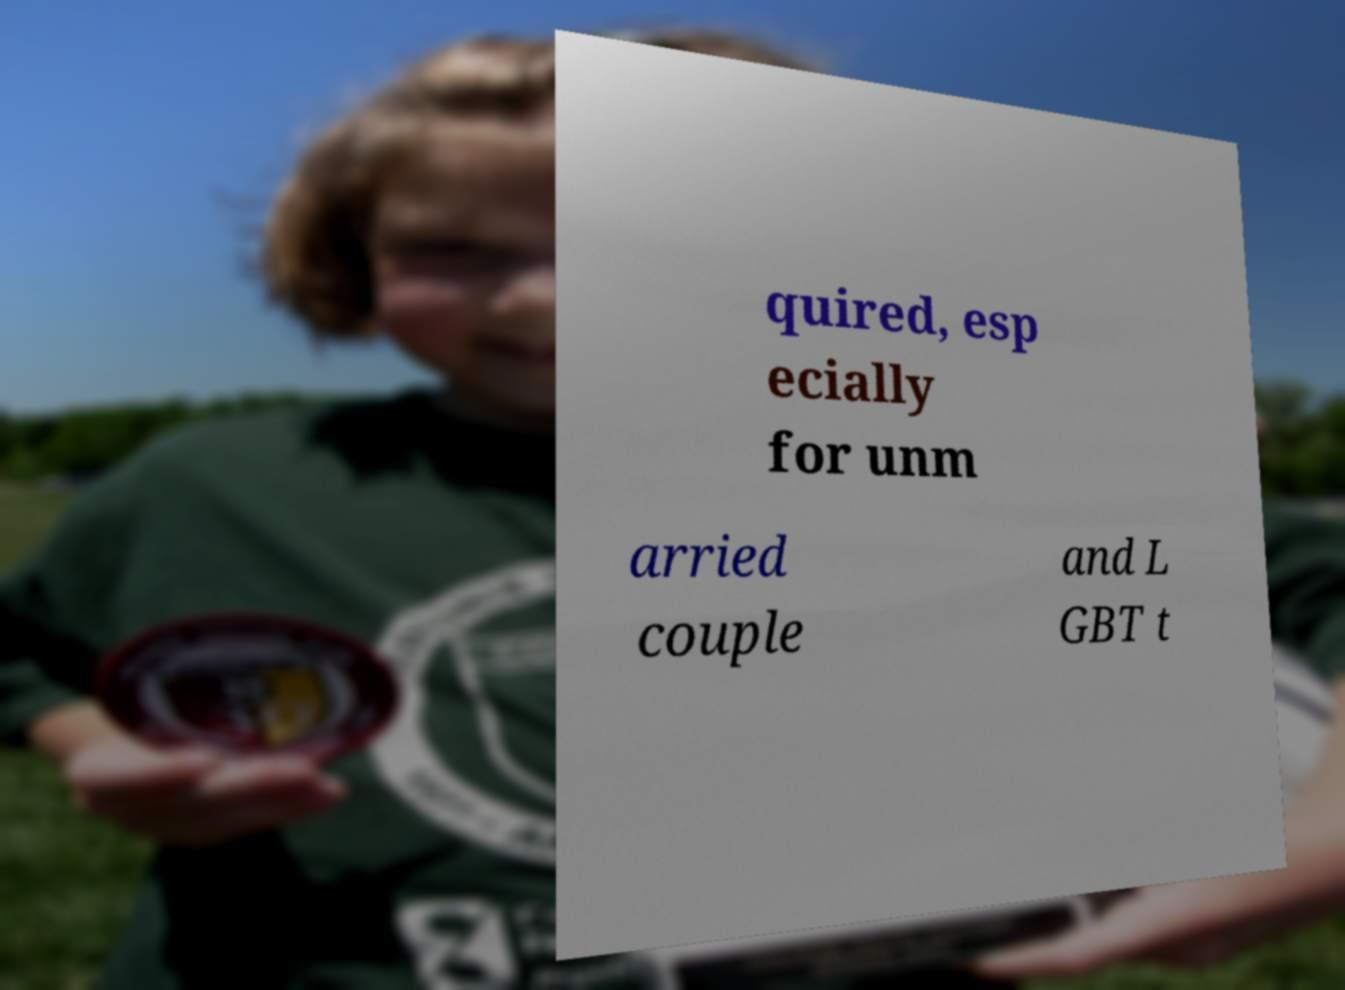Please identify and transcribe the text found in this image. quired, esp ecially for unm arried couple and L GBT t 